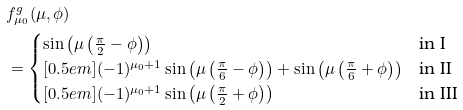Convert formula to latex. <formula><loc_0><loc_0><loc_500><loc_500>& f _ { \mu _ { 0 } } ^ { g } ( \mu , \phi ) \\ & = \begin{cases} \sin \left ( \mu \left ( \frac { \pi } { 2 } - \phi \right ) \right ) & \text {in I} \\ [ 0 . 5 e m ] ( - 1 ) ^ { \mu _ { 0 } + 1 } \sin \left ( \mu \left ( \frac { \pi } { 6 } - \phi \right ) \right ) + \sin \left ( \mu \left ( \frac { \pi } { 6 } + \phi \right ) \right ) & \text {in II} \\ [ 0 . 5 e m ] ( - 1 ) ^ { \mu _ { 0 } + 1 } \sin \left ( \mu \left ( \frac { \pi } { 2 } + \phi \right ) \right ) & \text {in III} \end{cases}</formula> 